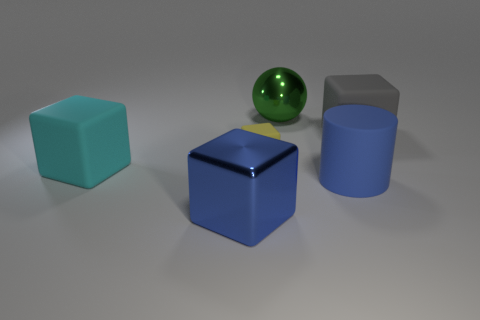Subtract 1 blocks. How many blocks are left? 3 Add 4 large purple metallic blocks. How many objects exist? 10 Subtract all spheres. How many objects are left? 5 Subtract all cyan rubber balls. Subtract all cyan rubber objects. How many objects are left? 5 Add 1 big matte things. How many big matte things are left? 4 Add 6 small yellow matte cubes. How many small yellow matte cubes exist? 7 Subtract 0 brown cubes. How many objects are left? 6 